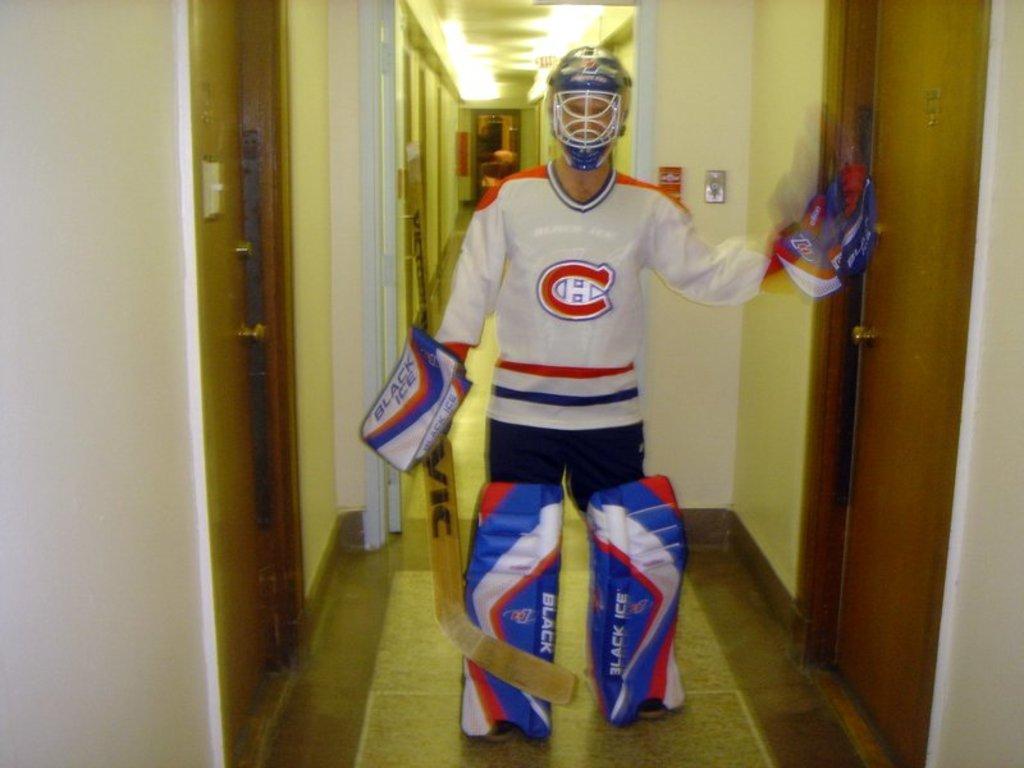Could you give a brief overview of what you see in this image? In this image I can see a man is standing and I can see he is wearing sports wear. I can also see he is wearing gloves, a helmet and leg pads. I can also see he is holding a stick and on the both sides of the image I can see number of doors. In the background I can see number of lights on the ceiling. 